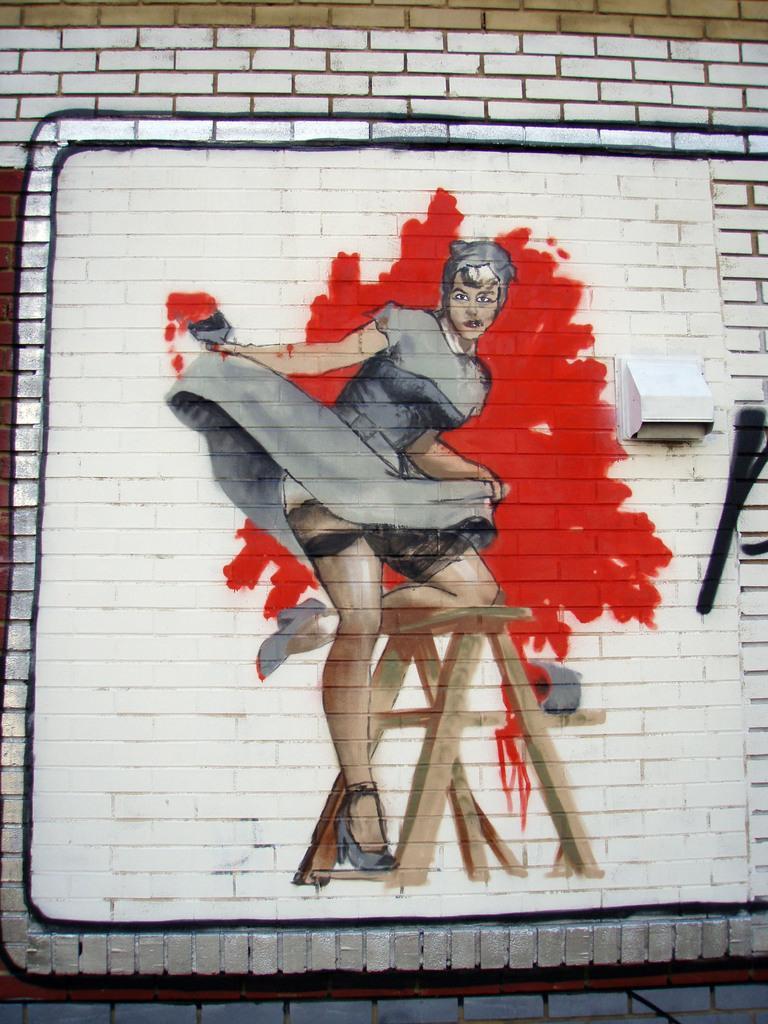Could you give a brief overview of what you see in this image? In this image there is a wall, on that wall there is a painting of of a female, she is standing on a table. 